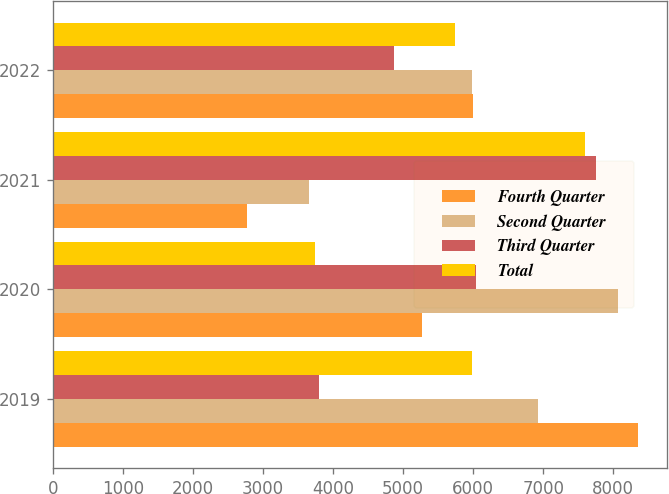<chart> <loc_0><loc_0><loc_500><loc_500><stacked_bar_chart><ecel><fcel>2019<fcel>2020<fcel>2021<fcel>2022<nl><fcel>Fourth Quarter<fcel>8354<fcel>5264<fcel>2772<fcel>5998<nl><fcel>Second Quarter<fcel>6927<fcel>8071<fcel>3651<fcel>5991<nl><fcel>Third Quarter<fcel>3806<fcel>6039<fcel>7757<fcel>4869<nl><fcel>Total<fcel>5991<fcel>3746<fcel>7601<fcel>5744<nl></chart> 